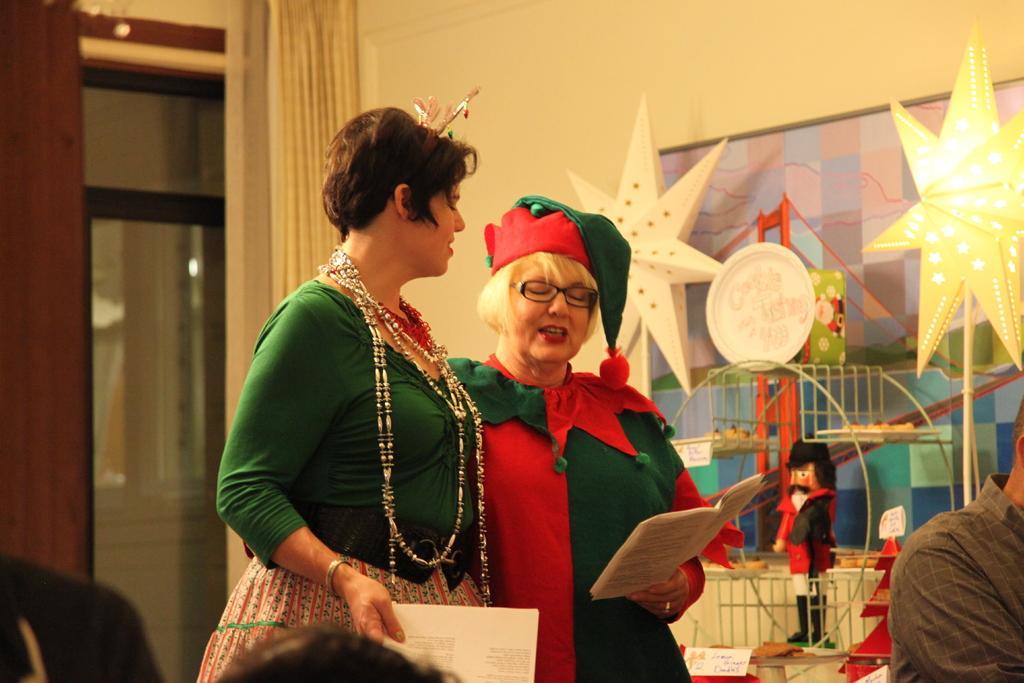Could you give a brief overview of what you see in this image? In the center of the image two ladies are standing and holding book in their hand. In the background of the image we can see glass door, curtain, wall, decor, lights are there. At the bottom of the image some persons are there. 